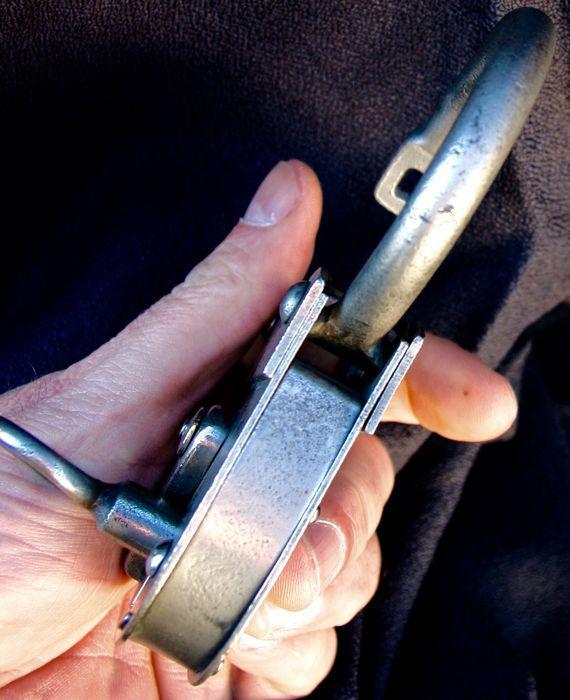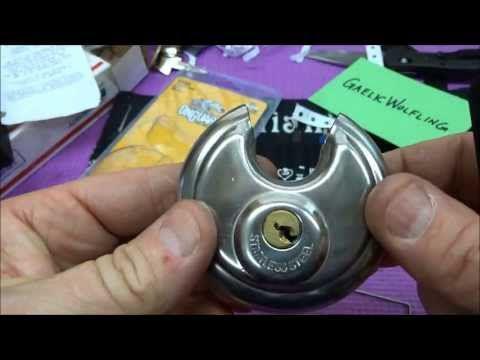The first image is the image on the left, the second image is the image on the right. Examine the images to the left and right. Is the description "There are two locks attached to bags." accurate? Answer yes or no. No. The first image is the image on the left, the second image is the image on the right. Examine the images to the left and right. Is the description "There are two thumbs in on e of the images." accurate? Answer yes or no. Yes. 